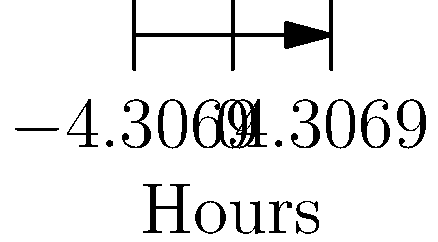Given the team availability chart above, which 2-hour time slot would accommodate the most team members for a meeting? To find the optimal 2-hour time slot for a meeting, we need to analyze the overlapping availability of team members:

1. Identify each team member's availability:
   - Alice: 9:00 - 17:00
   - Bob: 10:00 - 18:00
   - Charlie: 8:00 - 16:00
   - Diana: 11:00 - 19:00
   - Eva: 9:00 - 17:00
   - Frank: 10:00 - 18:00

2. Find the common availability window:
   The earliest start time is 11:00 (Diana), and the earliest end time is 16:00 (Charlie).
   So, the common window is 11:00 - 16:00.

3. Count team members available for each hour within this window:
   11:00 - 12:00: 6 members
   12:00 - 13:00: 6 members
   13:00 - 14:00: 6 members
   14:00 - 15:00: 6 members
   15:00 - 16:00: 6 members

4. Identify the 2-hour slot with the highest attendance:
   Any 2-hour slot between 11:00 and 16:00 would include all 6 team members.

5. Choose the optimal slot:
   For example, 13:00 - 15:00 would be in the middle of the common availability window, allowing buffer time before and after the meeting for most team members.

Therefore, the optimal 2-hour time slot that would accommodate the most team members (all 6) is 13:00 - 15:00.
Answer: 13:00 - 15:00 